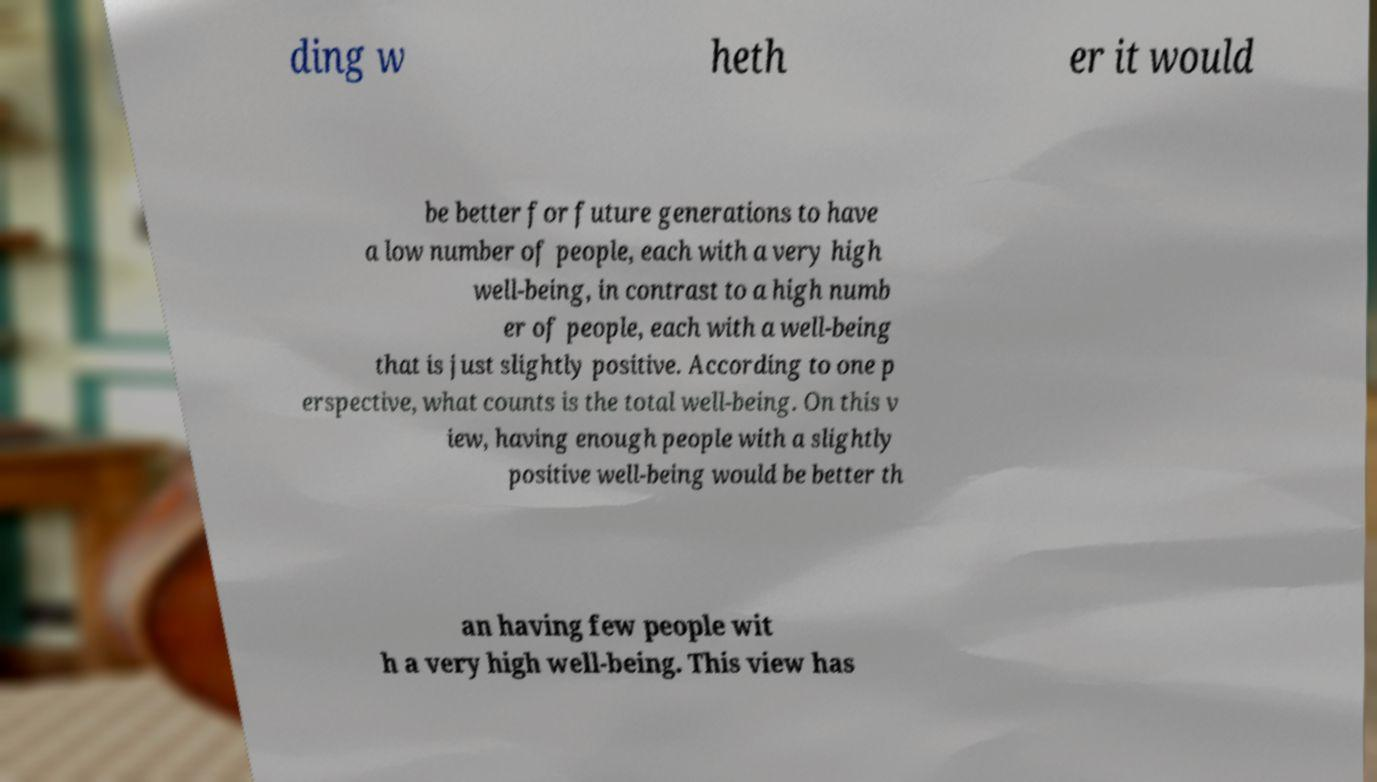Can you accurately transcribe the text from the provided image for me? ding w heth er it would be better for future generations to have a low number of people, each with a very high well-being, in contrast to a high numb er of people, each with a well-being that is just slightly positive. According to one p erspective, what counts is the total well-being. On this v iew, having enough people with a slightly positive well-being would be better th an having few people wit h a very high well-being. This view has 